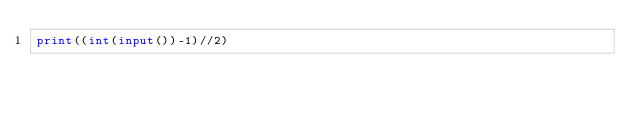<code> <loc_0><loc_0><loc_500><loc_500><_Python_>print((int(input())-1)//2)
</code> 